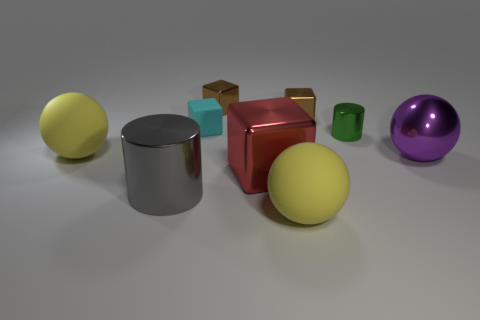Is the shape of the tiny matte thing the same as the big object on the right side of the green shiny thing?
Provide a short and direct response. No. What is the material of the tiny cyan block?
Your response must be concise. Rubber. The cyan rubber object that is the same shape as the large red metal object is what size?
Offer a very short reply. Small. How many other things are there of the same material as the big red block?
Your answer should be compact. 5. Are the big red object and the big yellow thing that is right of the tiny cyan rubber cube made of the same material?
Provide a succinct answer. No. Are there fewer small cyan rubber blocks in front of the large metal sphere than big matte things that are right of the big gray metallic cylinder?
Offer a very short reply. Yes. What is the color of the sphere in front of the gray shiny object?
Make the answer very short. Yellow. How many other objects are the same color as the tiny matte block?
Your answer should be very brief. 0. Does the cylinder that is in front of the green metal cylinder have the same size as the small green metallic thing?
Provide a succinct answer. No. What number of tiny shiny objects are on the left side of the large cylinder?
Your answer should be very brief. 0. 